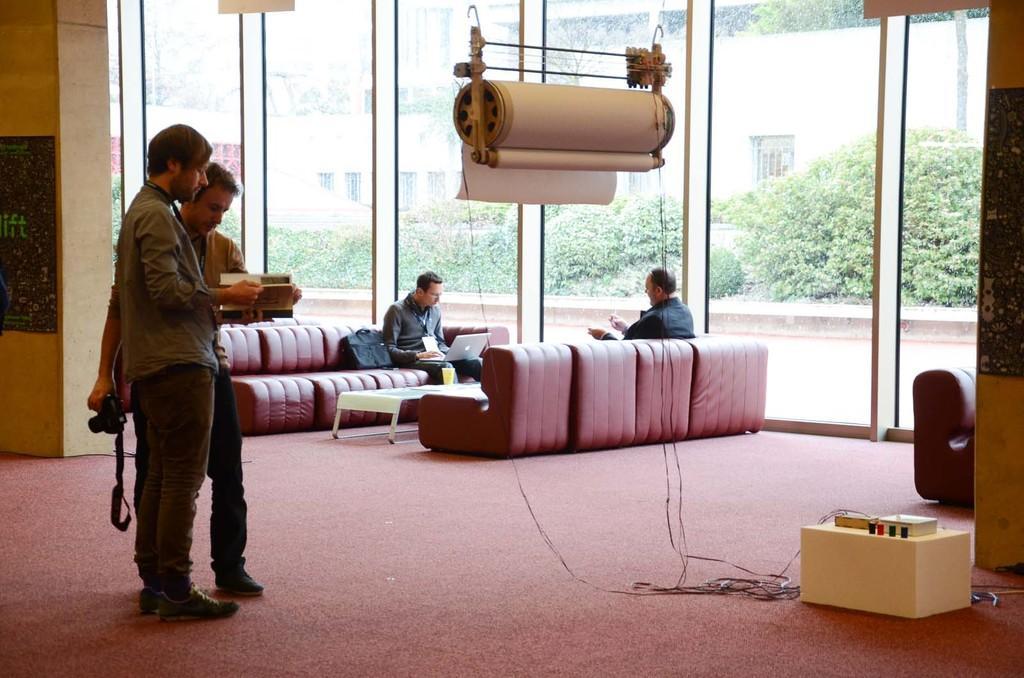Can you describe this image briefly? This picture is of inside the room. On the left there is a man standing, holding a book and looking into the book, behind him there is another man holding a camera, standing and looking into the boo. In the center there is a man sitting on the couch. On the left there is a man sitting on the couch and working on the laptop. We can see a glass placed on the top of the center table. In the background we can see the buildings, plants and a machine. On the right we can see a machine placed on the ground. 